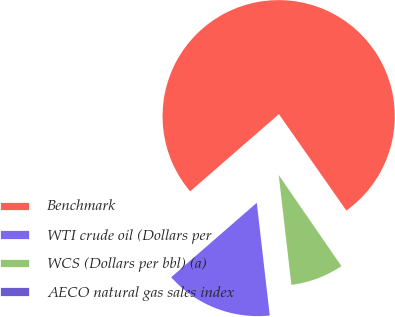Convert chart. <chart><loc_0><loc_0><loc_500><loc_500><pie_chart><fcel>Benchmark<fcel>WTI crude oil (Dollars per<fcel>WCS (Dollars per bbl) (a)<fcel>AECO natural gas sales index<nl><fcel>76.68%<fcel>15.43%<fcel>7.77%<fcel>0.12%<nl></chart> 